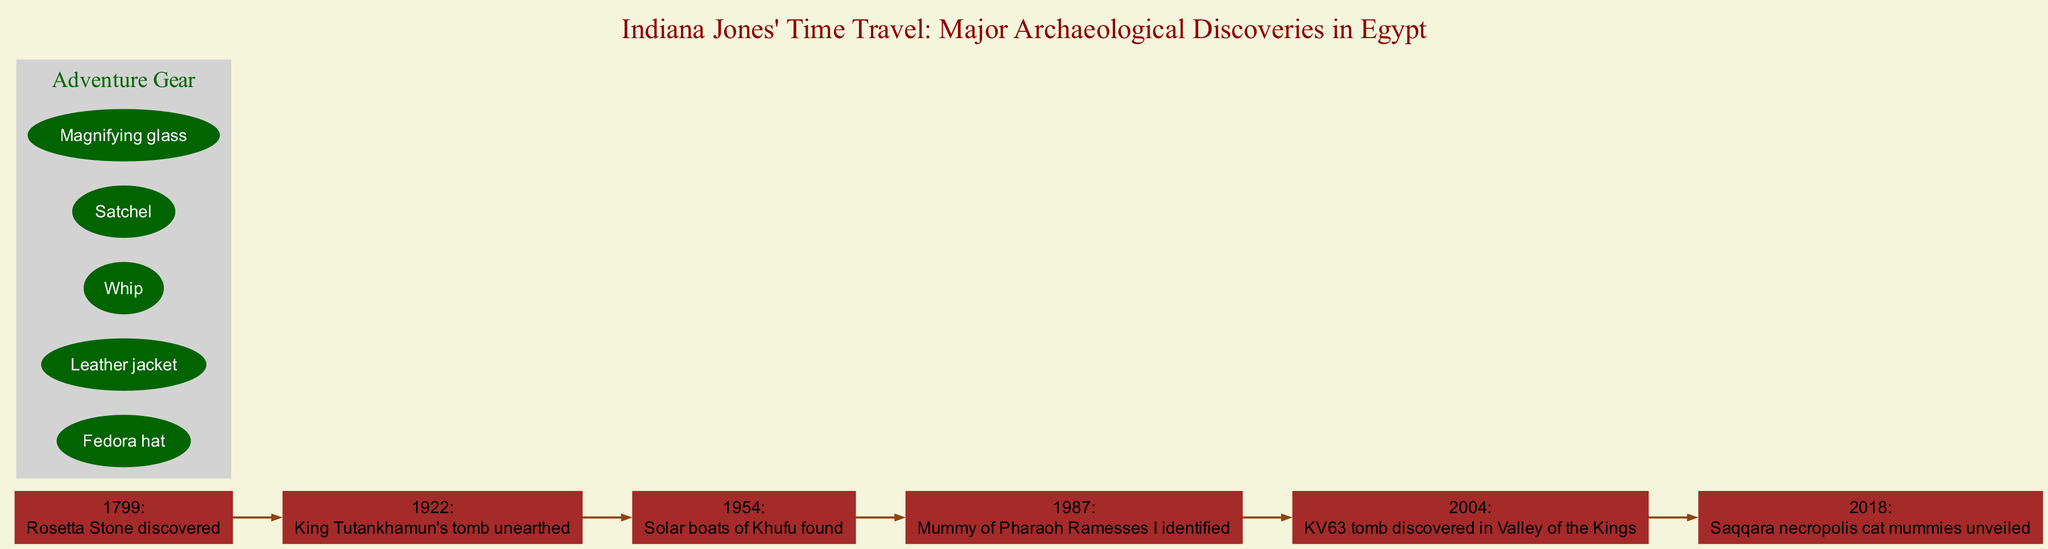What year was the Rosetta Stone discovered? The diagram specifically lists the Rosetta Stone discovery as occurring in 1799. It is the first event in the timeline, making it easy to locate.
Answer: 1799 What event occurred right after King Tutankhamun's tomb was unearthed? The event that follows King Tutankhamun's tomb, which was discovered in 1922, is the finding of the Solar boats of Khufu in 1954. The timeline shows a direct progression of events.
Answer: Solar boats of Khufu found How many major archaeological discoveries are shown in the timeline? By counting each listed event in the timeline from the diagram, there are a total of six events documented from the Rosetta Stone in 1799 to the unveiling of cat mummies in 2018.
Answer: 6 What discovery is represented by a cat statue icon? The cat statue icon corresponds to the event that details the unveiling of Saqqara necropolis cat mummies. By identifying the descriptions attached to the icons, the answer can be determined.
Answer: Saqqara necropolis cat mummies unveiled Which discovery happened in 1987? The timeline clearly indicates that in 1987, the mummy of Pharaoh Ramesses I was identified. This specific event is listed chronologically on the diagram.
Answer: Mummy of Pharaoh Ramesses I identified What is the earliest event listed in the timeline? Reviewing the timeline, the earliest event marked is the discovery of the Rosetta Stone in 1799, which clearly stands as the starting point of the timeline.
Answer: Rosetta Stone discovered Which items are included in the adventure gear list? The gear listed includes a Fedora hat, Leather jacket, Whip, Satchel, and Magnifying glass. Each item is presented in a separate node under the adventure gear section.
Answer: Fedora hat, Leather jacket, Whip, Satchel, Magnifying glass Which event marked the discovery of a tomb in the Valley of the Kings? The discovery noted for the tomb located in the Valley of the Kings is KV63, which was discovered in 2004. This events leads into the timeline flow.
Answer: KV63 tomb discovered in Valley of the Kings What color are the nodes that represent the major events? The nodes that represent the major events are colored brown according to the attributes specified for the graph's nodes in the diagram.
Answer: Brown 